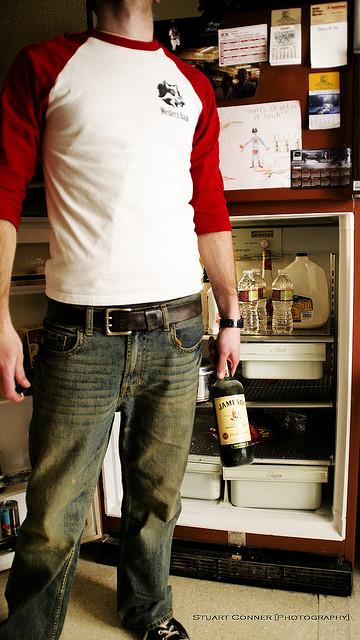What is the bottle of?
Keep it brief. Wine. Would this be a good photo to use as a profile picture if you wanted to conceal your identity?
Concise answer only. Yes. What appliance is the man standing in front of?
Give a very brief answer. Refrigerator. 